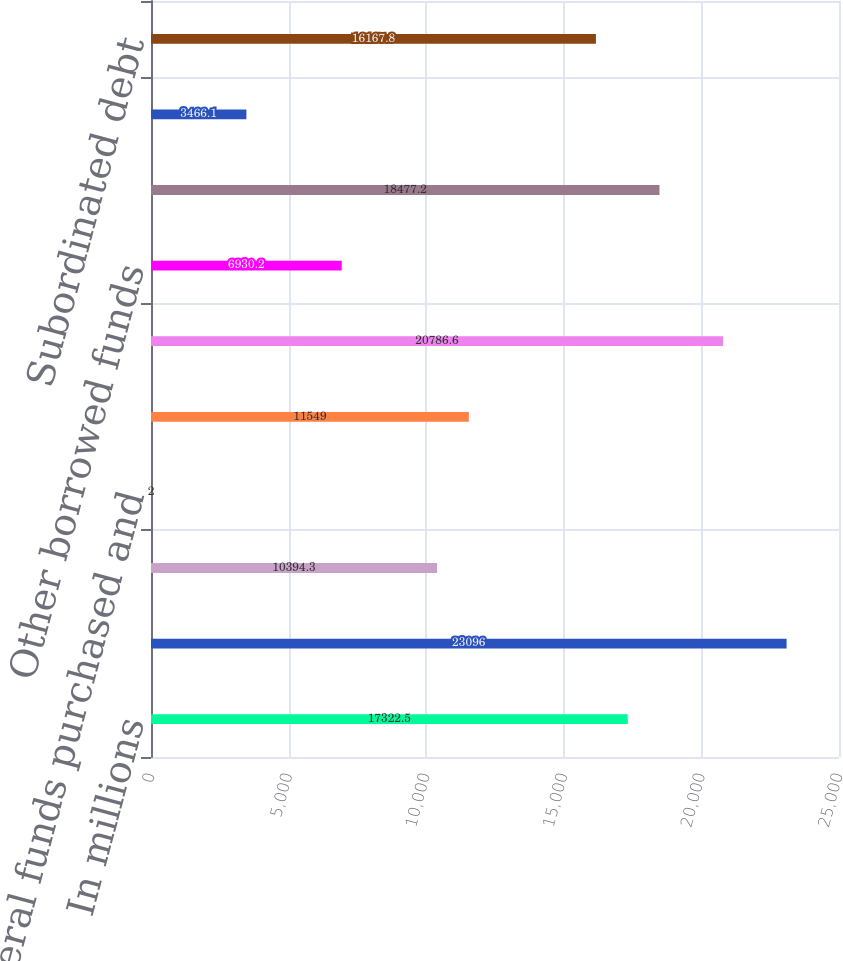Convert chart to OTSL. <chart><loc_0><loc_0><loc_500><loc_500><bar_chart><fcel>In millions<fcel>Noninterest-bearing deposits<fcel>Interest-bearing deposits<fcel>Federal funds purchased and<fcel>Federal Home Loan borrowings<fcel>Commercial paper<fcel>Other borrowed funds<fcel>Bank notes and senior debt<fcel>Common and treasury stock<fcel>Subordinated debt<nl><fcel>17322.5<fcel>23096<fcel>10394.3<fcel>2<fcel>11549<fcel>20786.6<fcel>6930.2<fcel>18477.2<fcel>3466.1<fcel>16167.8<nl></chart> 